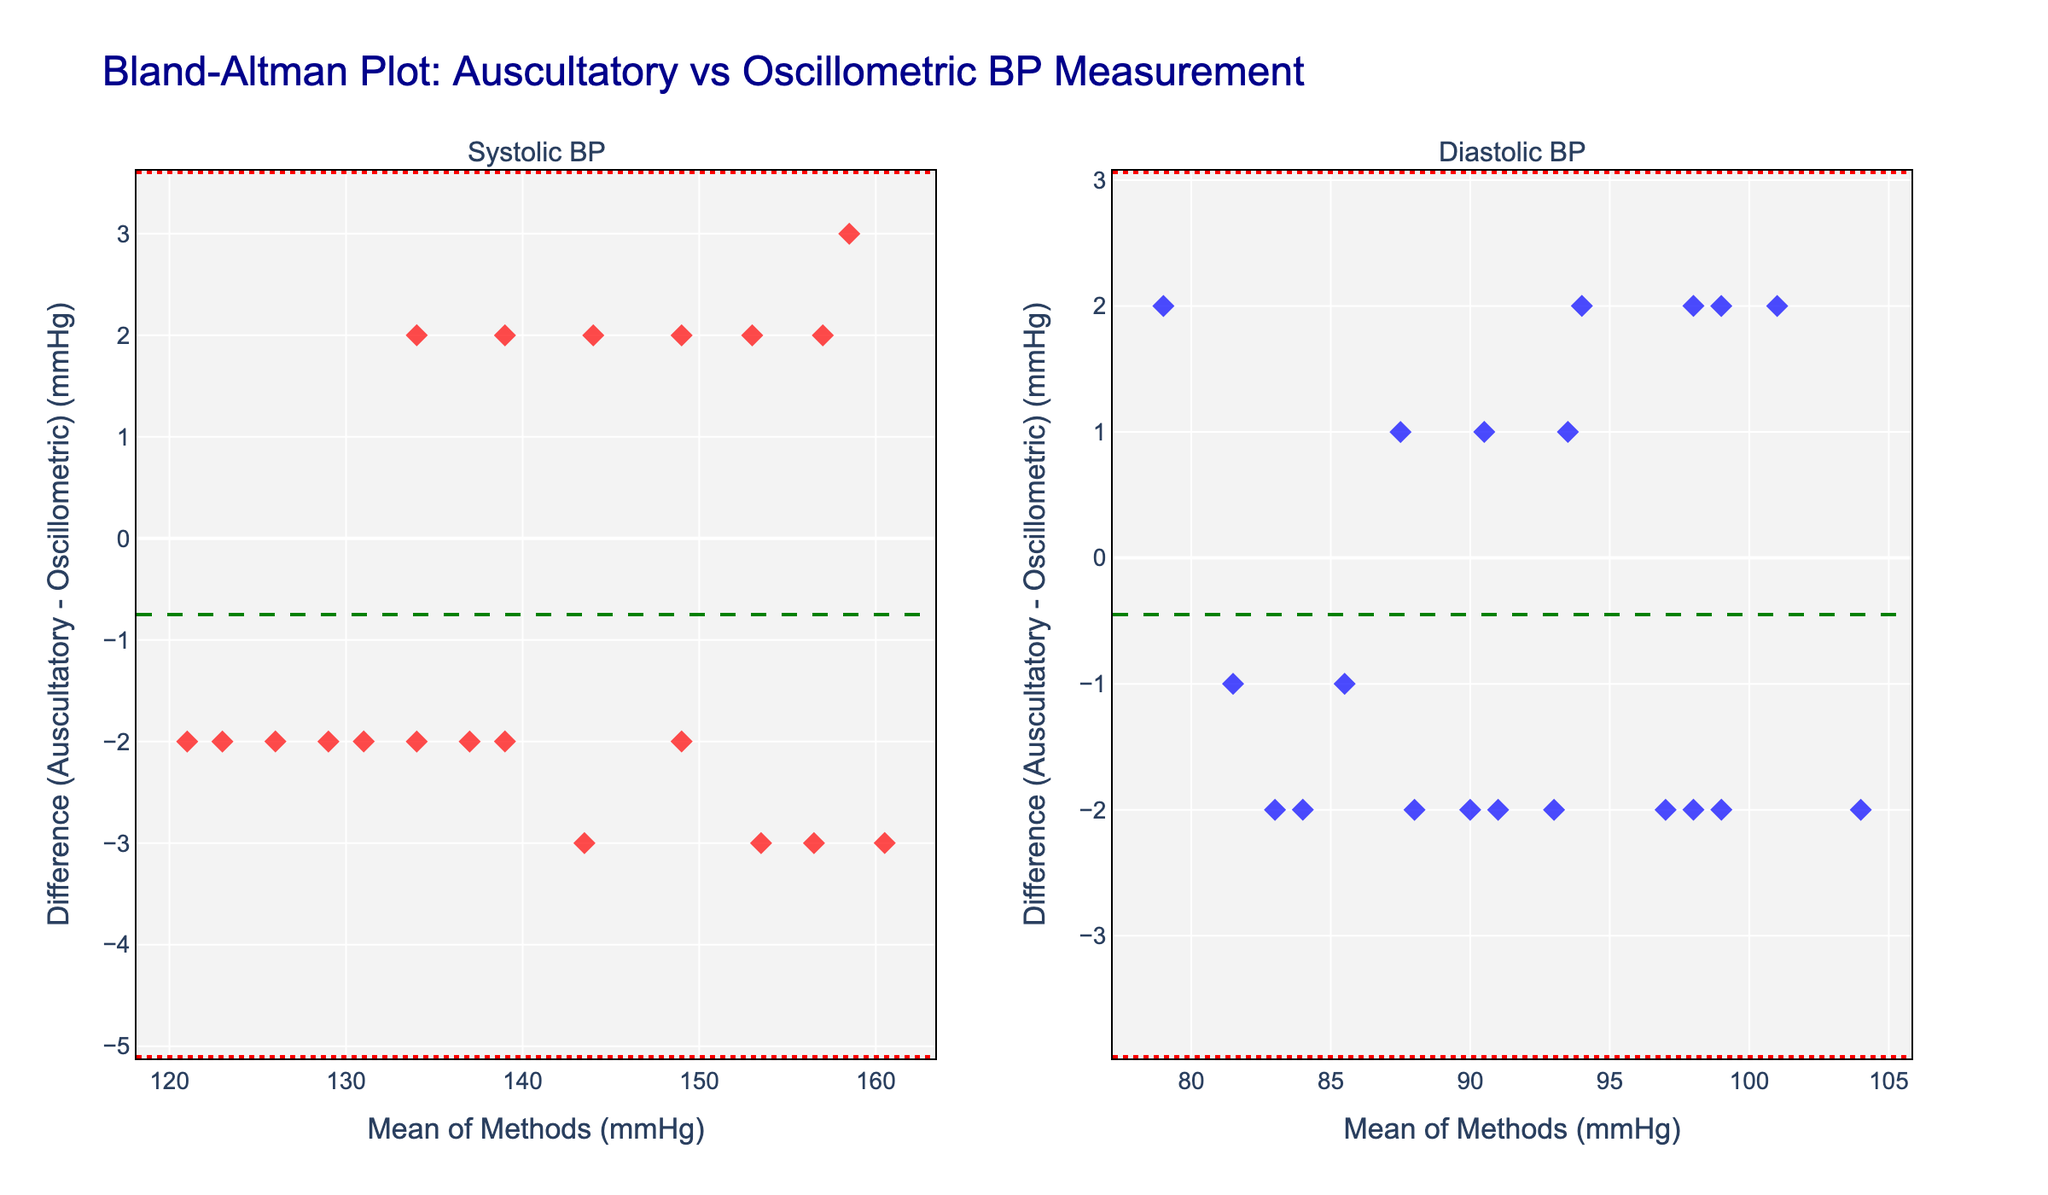What is the title of the plot? The title is located at the top center of the plot. It reads "Bland-Altman Plot: Auscultatory vs Oscillometric BP Measurement".
Answer: Bland-Altman Plot: Auscultatory vs Oscillometric BP Measurement What do the green dashed lines represent? The green dashed lines represent the mean differences between Auscultatory and Oscillometric BP measurements, shown for both systolic and diastolic blood pressures.
Answer: Mean differences What is the mean difference for systolic BP? The green dashed line in the first subplot represents the mean difference. Observing where it crosses the y-axis will give us this value.
Answer: ~ -0.95 mmHg What are the upper and lower limits of agreement for systolic BP? The red dotted lines in the first subplot represent the upper and lower limits of agreement. Check where they intersect the y-axis.
Answer: ~ 4.87 mmHg (upper), ~ -6.77 mmHg (lower) Is the mean difference for diastolic BP above or below zero? Check the green dashed line in the second subplot. If it is above the y=0 line, the mean difference is above zero; otherwise, it is below zero.
Answer: Above zero Which has a greater range of differences, systolic BP or diastolic BP? Compare the distance between the upper and lower red dotted lines in both subplots. The subplot with the larger distance represents the greater range of differences.
Answer: Diastolic BP How many data points appear to be outside the limits of agreement for systolic BP? Count the number of points outside the range of the red dotted lines in the first subplot.
Answer: 0 What does a point far from the mean difference line indicate? A point far from the mean difference line indicates a significant discrepancy between the Auscultatory and Oscillometric measurements for that specific individual.
Answer: Significant discrepancy What is the mean of systolic BP measurements for the dataset if the mean difference is -0.95 and the mean Oscillometric SBP is known to be 139.05 mmHg? Add the mean difference to the mean Oscillometric SBP to find the mean Auscultatory SBP: 139.05 + (-0.95) = 138.10 mmHg
Answer: 138.10 mmHg Compare the variability of systolic and diastolic BP differences. Which has more spread? Use the standard deviations deduced from the lengths between the green and red lines relative to each subplot. A larger spread implies greater variability.
Answer: Diastolic BP 